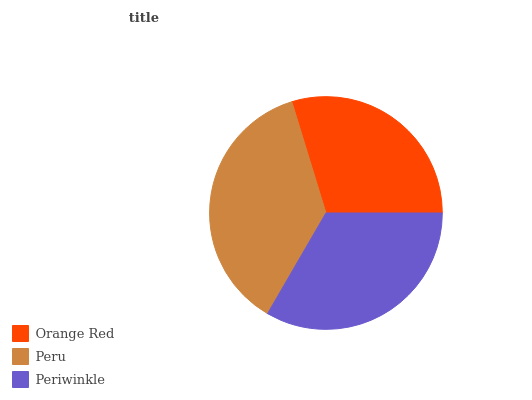Is Orange Red the minimum?
Answer yes or no. Yes. Is Peru the maximum?
Answer yes or no. Yes. Is Periwinkle the minimum?
Answer yes or no. No. Is Periwinkle the maximum?
Answer yes or no. No. Is Peru greater than Periwinkle?
Answer yes or no. Yes. Is Periwinkle less than Peru?
Answer yes or no. Yes. Is Periwinkle greater than Peru?
Answer yes or no. No. Is Peru less than Periwinkle?
Answer yes or no. No. Is Periwinkle the high median?
Answer yes or no. Yes. Is Periwinkle the low median?
Answer yes or no. Yes. Is Orange Red the high median?
Answer yes or no. No. Is Peru the low median?
Answer yes or no. No. 